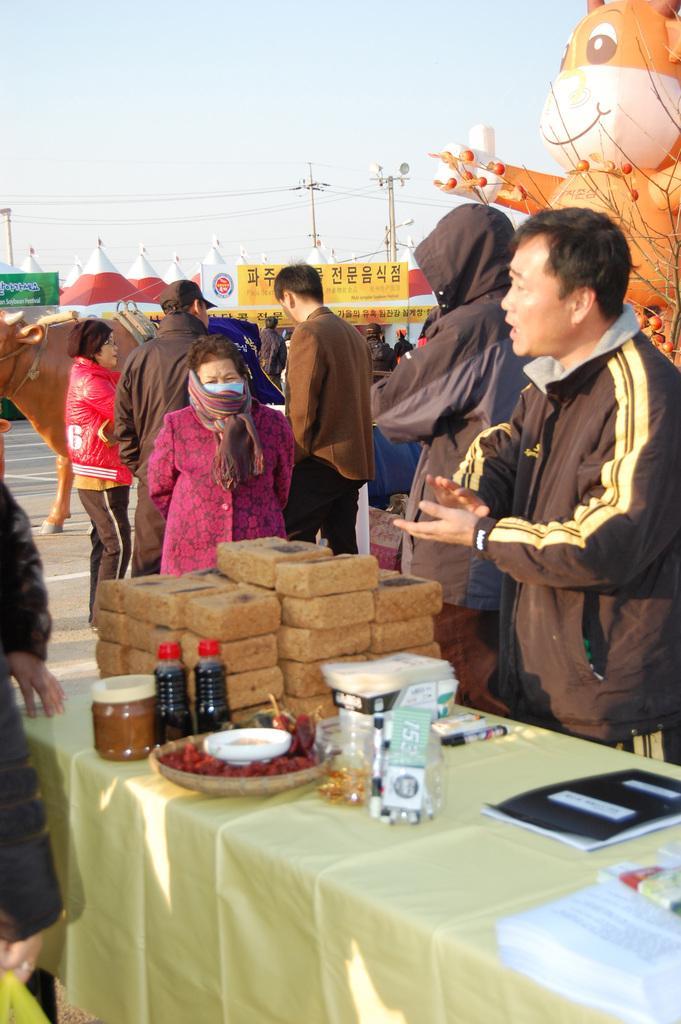Please provide a concise description of this image. In this picture outside of the city. There is a group of a people. They are standing on a roadside. There is a table. There is a bottle,plate,jar,paper on a table. We can see in background sky,trees and street lights. On the right side we have a another person. He is talking. 